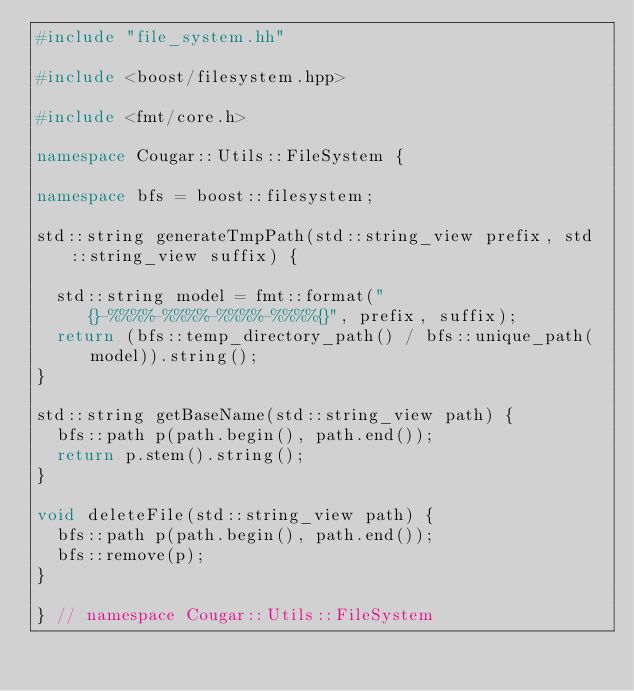<code> <loc_0><loc_0><loc_500><loc_500><_C++_>#include "file_system.hh"

#include <boost/filesystem.hpp>

#include <fmt/core.h>

namespace Cougar::Utils::FileSystem {

namespace bfs = boost::filesystem;

std::string generateTmpPath(std::string_view prefix, std::string_view suffix) {

  std::string model = fmt::format("{}-%%%%-%%%%-%%%%-%%%%{}", prefix, suffix);
  return (bfs::temp_directory_path() / bfs::unique_path(model)).string();
}

std::string getBaseName(std::string_view path) {
  bfs::path p(path.begin(), path.end());
  return p.stem().string();
}

void deleteFile(std::string_view path) {
  bfs::path p(path.begin(), path.end());
  bfs::remove(p);
}

} // namespace Cougar::Utils::FileSystem</code> 